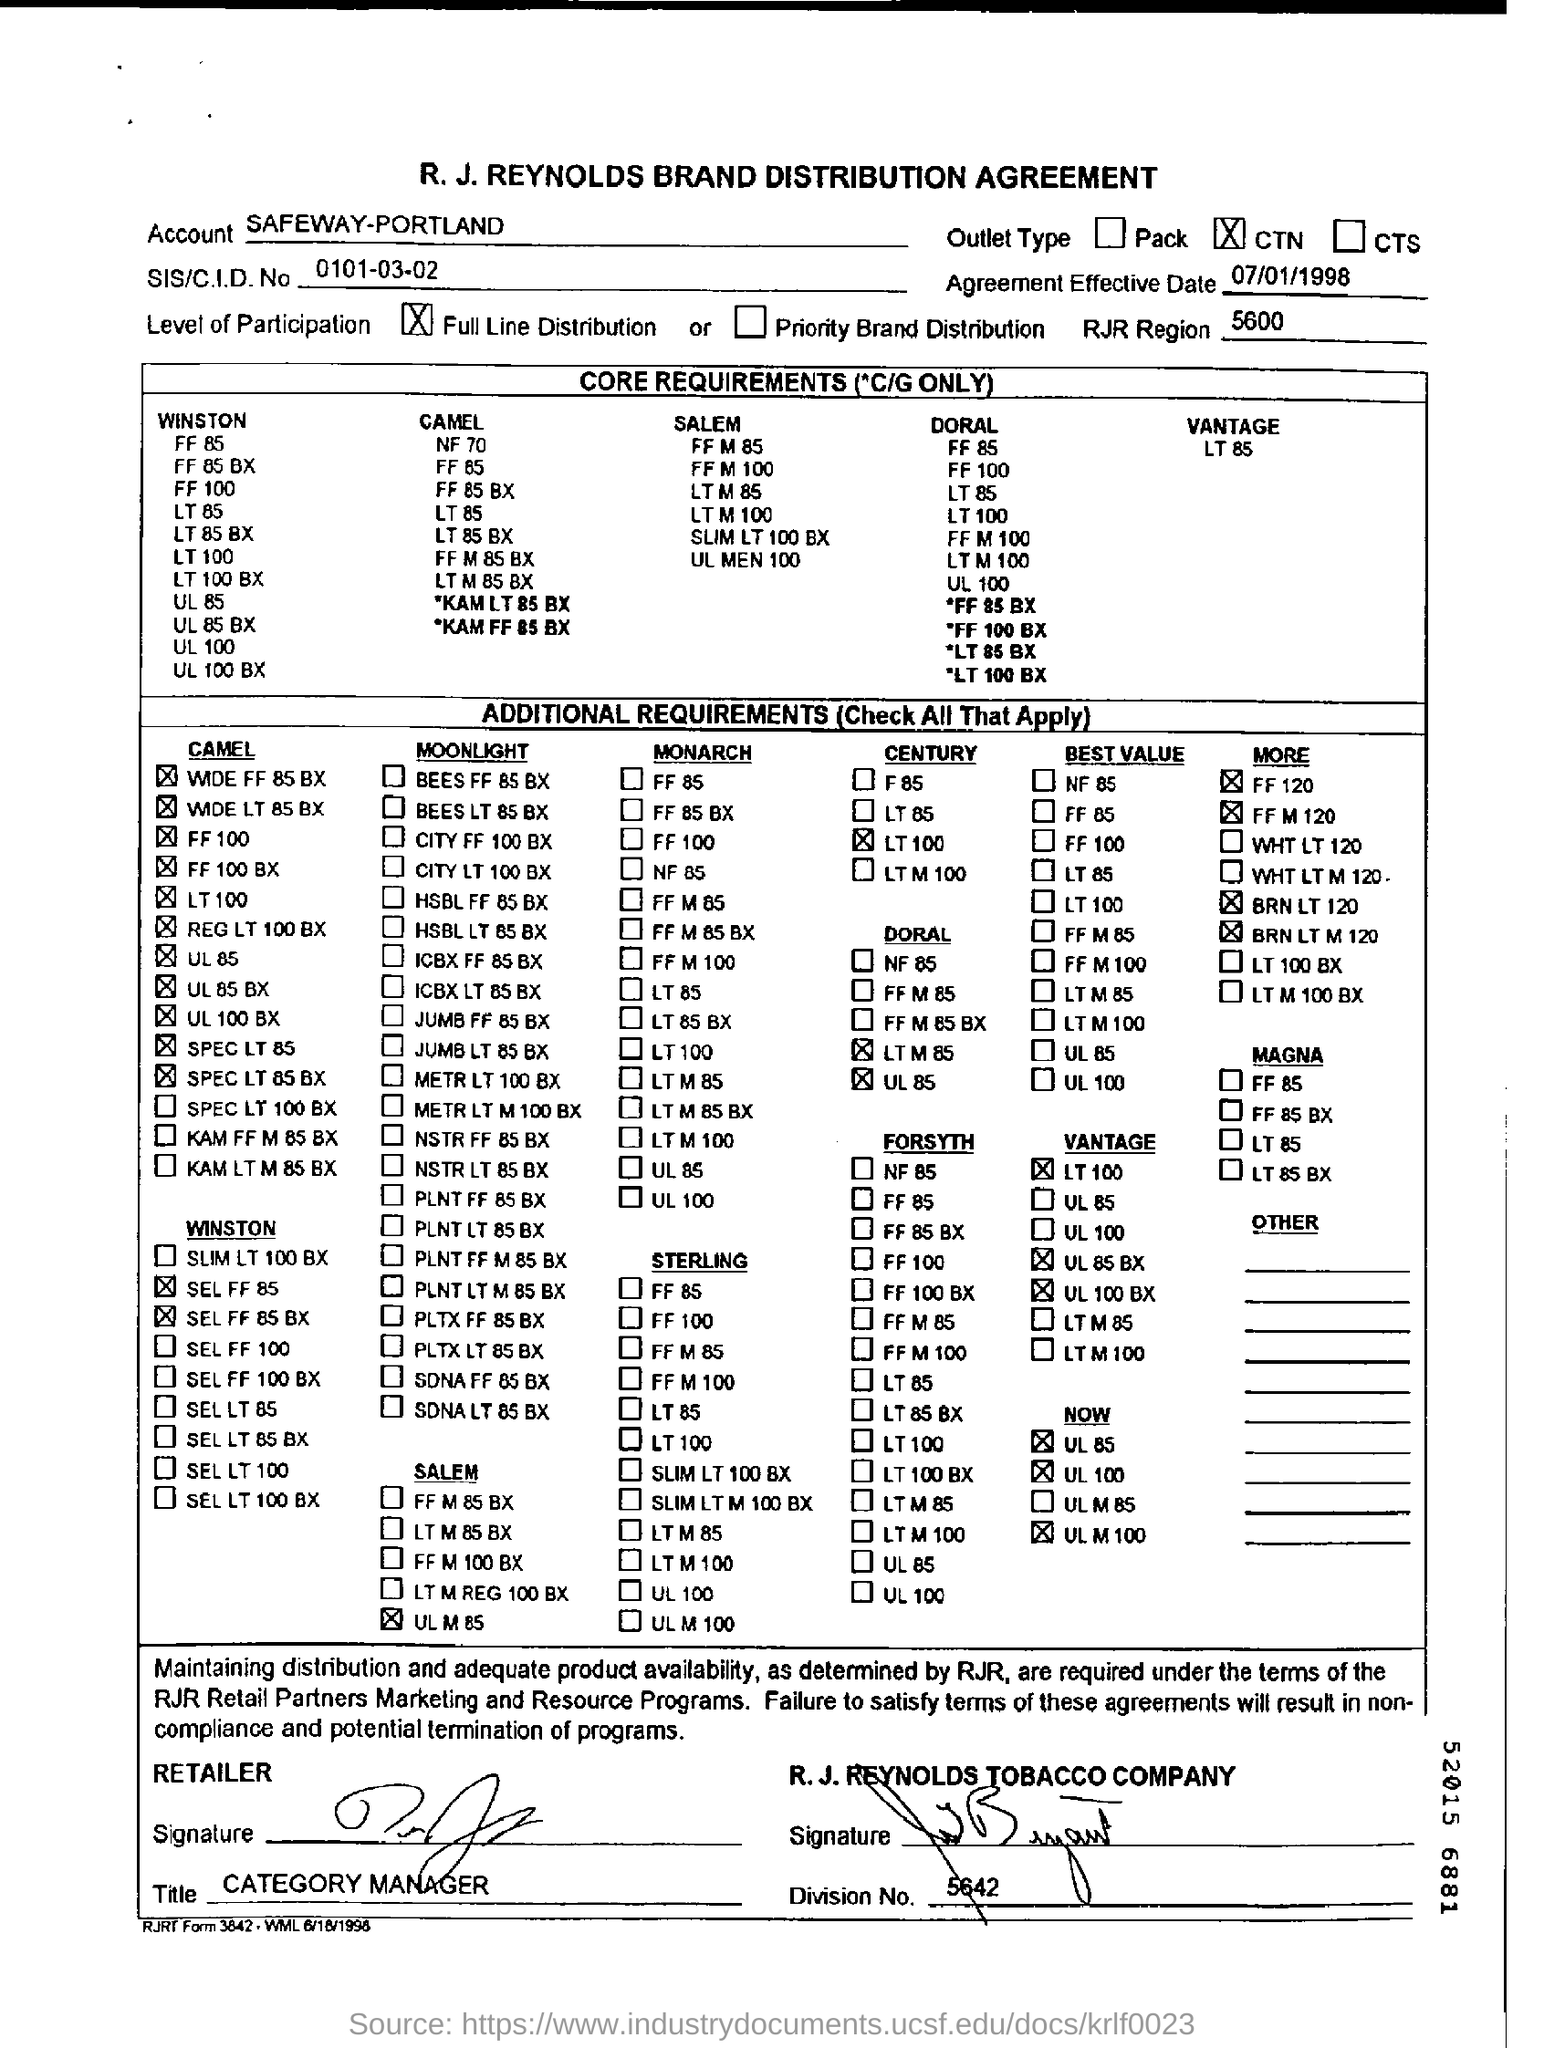Specify some key components in this picture. The person who signed from the retailer side is the Category Manager. The Agreement Effective Date is July 1, 1998. 